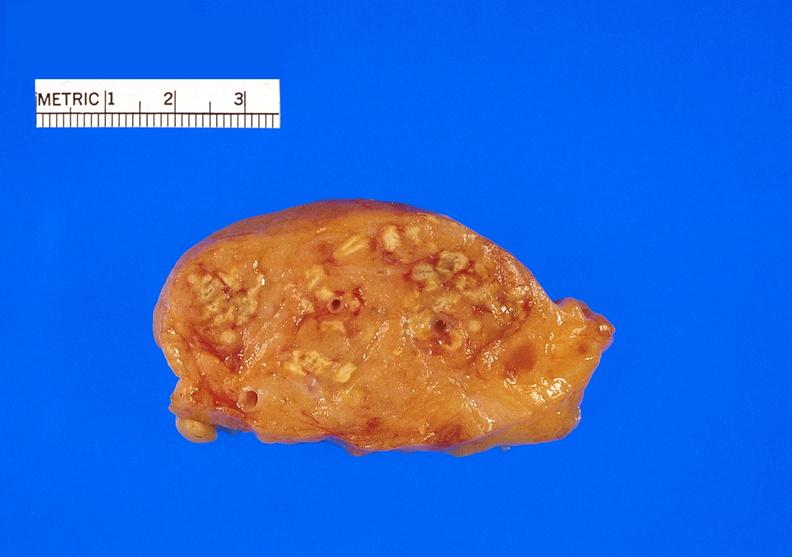does this image show pancreatic fat necrosis?
Answer the question using a single word or phrase. Yes 